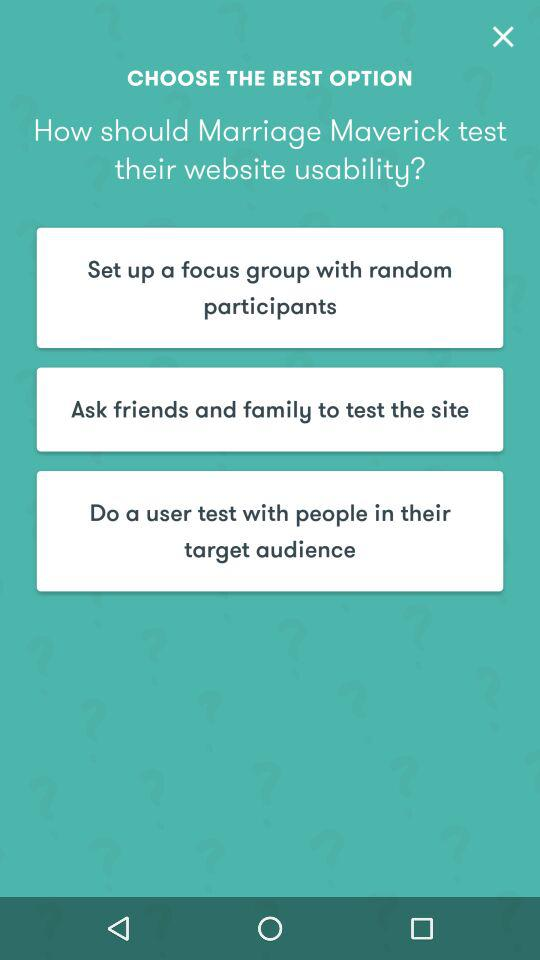How many options are there to test the website usability?
Answer the question using a single word or phrase. 3 